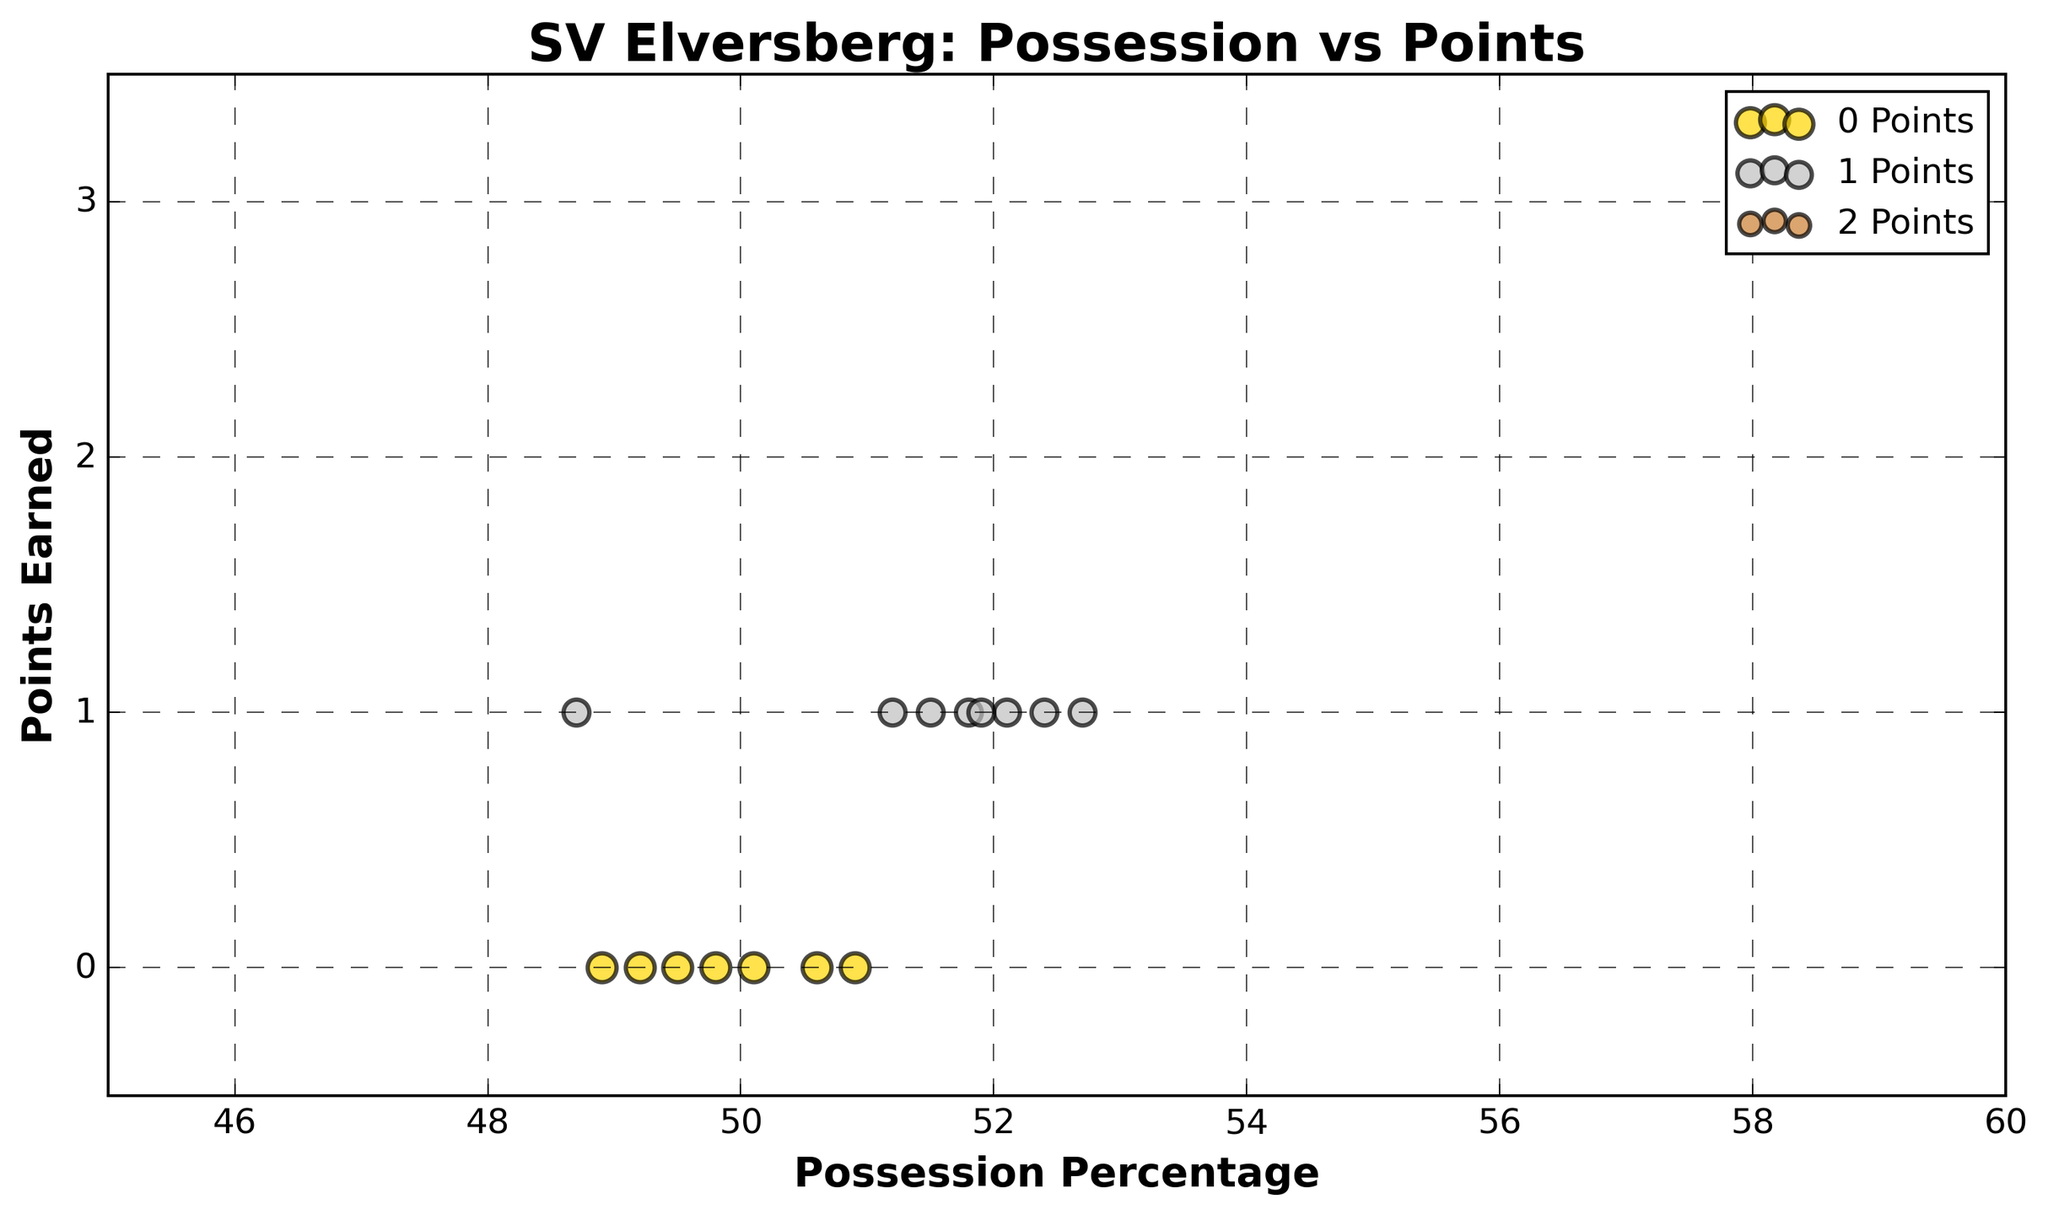What is the color associated with matches where SV Elversberg earned 3 points? The color associated with 3 points in the scatter plot legend is displayed. This color is used for all data points where SV Elversberg earned 3 points.
Answer: Gold Between which two values does the "Possession Percentage" axis range? The x-axis label "Possession Percentage" indicates the axis range. The scatter plot shows possession percentages from the minimum to the maximum value indicated on the axis.
Answer: 45 to 60 How many matches did SV Elversberg earn 1 point? From the scatter plot, count the number of non-overlapping data points in the 1 point category, as indicated by the color and number of points in that cluster.
Answer: 8 If you sum the possession percentages for matches where SV Elversberg earned 0 points, what is the total? Sum the "Possession Percentage" values for points with different visual markers colored accordingly. The data corresponding to 0 points should be summed. (50.9 + 49.5 + 50.1 + 48.9 + 49.8 + 50.6 + 49.2)
Answer: 349.0 What is the most frequent point outcome for matches where SV Elversberg's possession was above 55%? Examine the scatter plot's data points where possession percentage is greater than 55%, and observe the most frequently occurring data points' color or label.
Answer: 3 points Which label represents the cluster with the largest visual size? Based on the scatter plot, identify the category of points that use the marker with the largest diameter. This visual marker size is noted in the legend.
Answer: 0 points Comparing the matches where SV Elversberg had a possession percentage of 52% and 56%, which earning outcome is more common? Look at the scatter plot and observe the points near 52% and 56%. Compare which points are more frequent in each case.
Answer: 3 points Does the plot trend indicate that higher possession percentages generally correspond to more points earned? Evaluate the scatter plot trend of points and possession percentages, determining if there's a visible increase in points with increasing possession percentages.
Answer: Yes What range in possession percentage has the highest variability in points earned? Identify the possession percentage segment where points earned (0, 1, 3) are most varied. The scatter plot indicates this based on clustering of different colors in ranges.
Answer: 50%-52% What is the average possession percentage for matches where SV Elversberg earned 3 points? Average the possession percentages for data points visually identified as earning 3 points. (55.1 + 53.6 + 57.8 + 54.3 + 56.2 + 53.9 + 55.7 + 54.8 + 53.2 + 55.4 + 54.1 + 56.5 + 53.7 = 703.3 / 13)
Answer: 54.1 